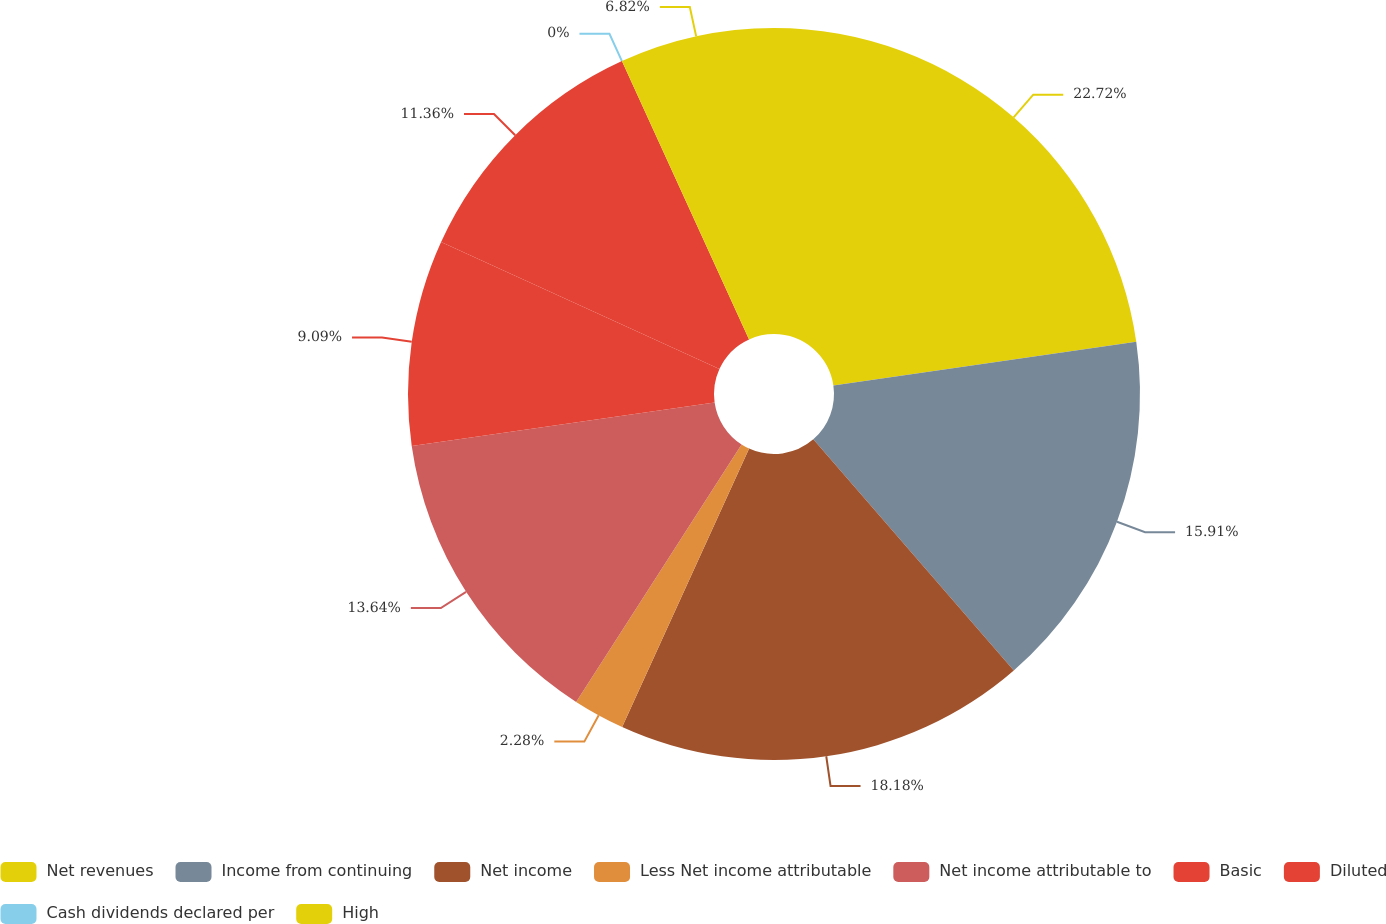<chart> <loc_0><loc_0><loc_500><loc_500><pie_chart><fcel>Net revenues<fcel>Income from continuing<fcel>Net income<fcel>Less Net income attributable<fcel>Net income attributable to<fcel>Basic<fcel>Diluted<fcel>Cash dividends declared per<fcel>High<nl><fcel>22.72%<fcel>15.91%<fcel>18.18%<fcel>2.28%<fcel>13.64%<fcel>9.09%<fcel>11.36%<fcel>0.0%<fcel>6.82%<nl></chart> 